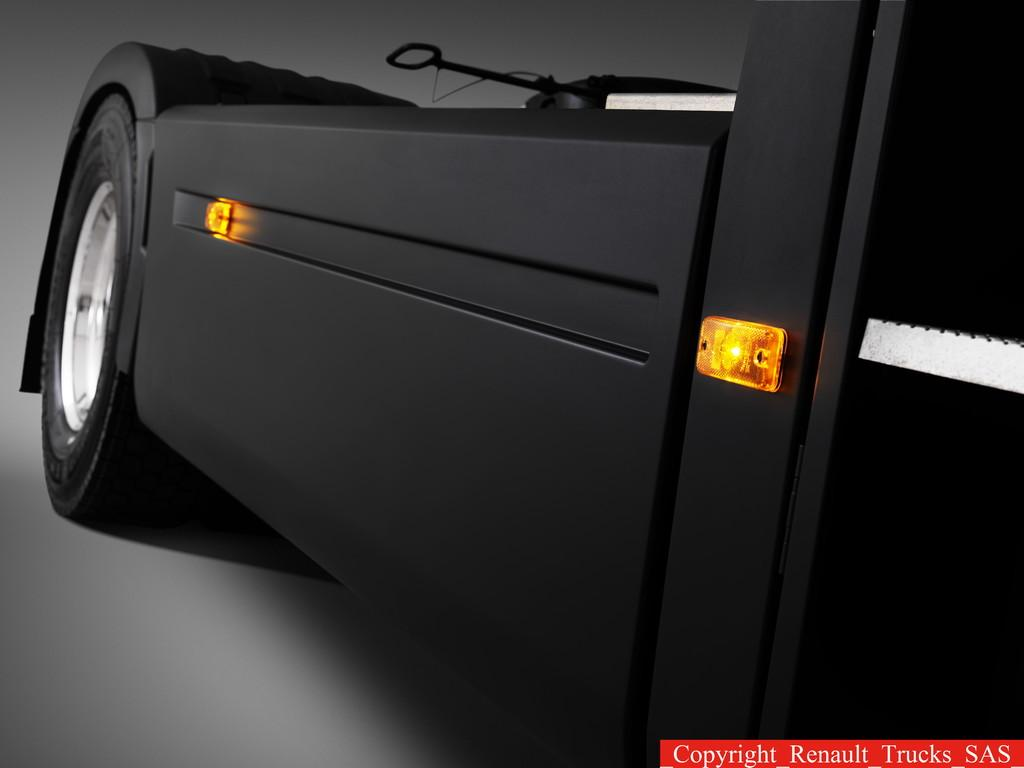What type of vehicle is in the image? There is a vehicle present in the image, but the specific type cannot be determined from the provided facts. Is there any text visible in the image? Yes, there is text in the bottom right corner of the image. What type of rifle is being used by the passenger in the vehicle? There is no passenger or rifle present in the image; it only features a vehicle and text. 